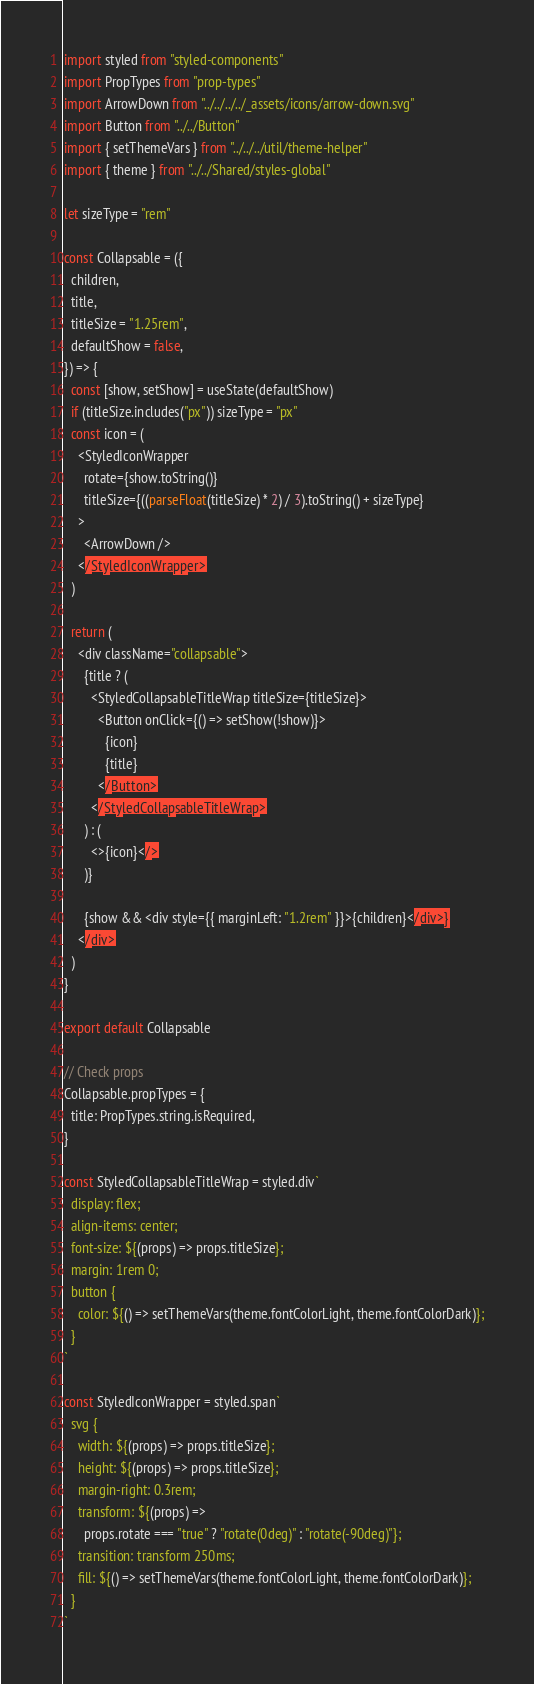Convert code to text. <code><loc_0><loc_0><loc_500><loc_500><_JavaScript_>import styled from "styled-components"
import PropTypes from "prop-types"
import ArrowDown from "../../../../_assets/icons/arrow-down.svg"
import Button from "../../Button"
import { setThemeVars } from "../../../util/theme-helper"
import { theme } from "../../Shared/styles-global"

let sizeType = "rem"

const Collapsable = ({
  children,
  title,
  titleSize = "1.25rem",
  defaultShow = false,
}) => {
  const [show, setShow] = useState(defaultShow)
  if (titleSize.includes("px")) sizeType = "px"
  const icon = (
    <StyledIconWrapper
      rotate={show.toString()}
      titleSize={((parseFloat(titleSize) * 2) / 3).toString() + sizeType}
    >
      <ArrowDown />
    </StyledIconWrapper>
  )

  return (
    <div className="collapsable">
      {title ? (
        <StyledCollapsableTitleWrap titleSize={titleSize}>
          <Button onClick={() => setShow(!show)}>
            {icon}
            {title}
          </Button>
        </StyledCollapsableTitleWrap>
      ) : (
        <>{icon}</>
      )}

      {show && <div style={{ marginLeft: "1.2rem" }}>{children}</div>}
    </div>
  )
}

export default Collapsable

// Check props
Collapsable.propTypes = {
  title: PropTypes.string.isRequired,
}

const StyledCollapsableTitleWrap = styled.div`
  display: flex;
  align-items: center;
  font-size: ${(props) => props.titleSize};
  margin: 1rem 0;
  button {
    color: ${() => setThemeVars(theme.fontColorLight, theme.fontColorDark)};
  }
`

const StyledIconWrapper = styled.span`
  svg {
    width: ${(props) => props.titleSize};
    height: ${(props) => props.titleSize};
    margin-right: 0.3rem;
    transform: ${(props) =>
      props.rotate === "true" ? "rotate(0deg)" : "rotate(-90deg)"};
    transition: transform 250ms;
    fill: ${() => setThemeVars(theme.fontColorLight, theme.fontColorDark)};
  }
`
</code> 